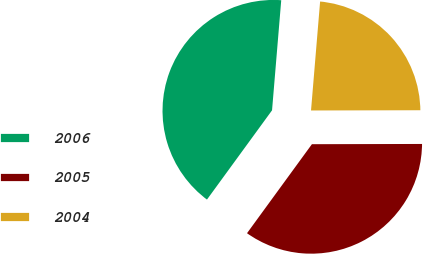Convert chart to OTSL. <chart><loc_0><loc_0><loc_500><loc_500><pie_chart><fcel>2006<fcel>2005<fcel>2004<nl><fcel>41.3%<fcel>35.06%<fcel>23.64%<nl></chart> 